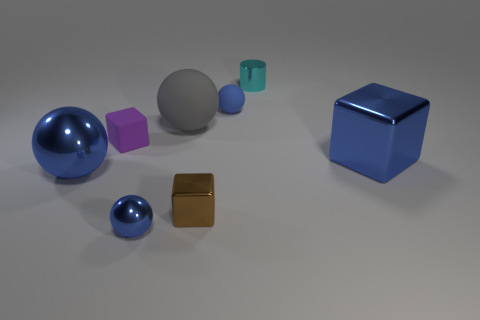What size is the metal block that is the same color as the tiny rubber sphere?
Your response must be concise. Large. Is there a large metallic object of the same color as the big metallic block?
Keep it short and to the point. Yes. There is a matte thing that is the same color as the large cube; what shape is it?
Your answer should be compact. Sphere. Is the material of the large sphere to the right of the tiny purple object the same as the tiny purple cube?
Give a very brief answer. Yes. What number of large objects are gray matte balls or rubber blocks?
Give a very brief answer. 1. The gray rubber ball has what size?
Your answer should be very brief. Large. Do the rubber cube and the blue sphere that is behind the large gray thing have the same size?
Keep it short and to the point. Yes. How many cyan objects are either tiny shiny cubes or tiny objects?
Provide a succinct answer. 1. What number of tiny metallic cubes are there?
Make the answer very short. 1. There is a blue metallic object that is right of the large gray thing; what size is it?
Your response must be concise. Large. 